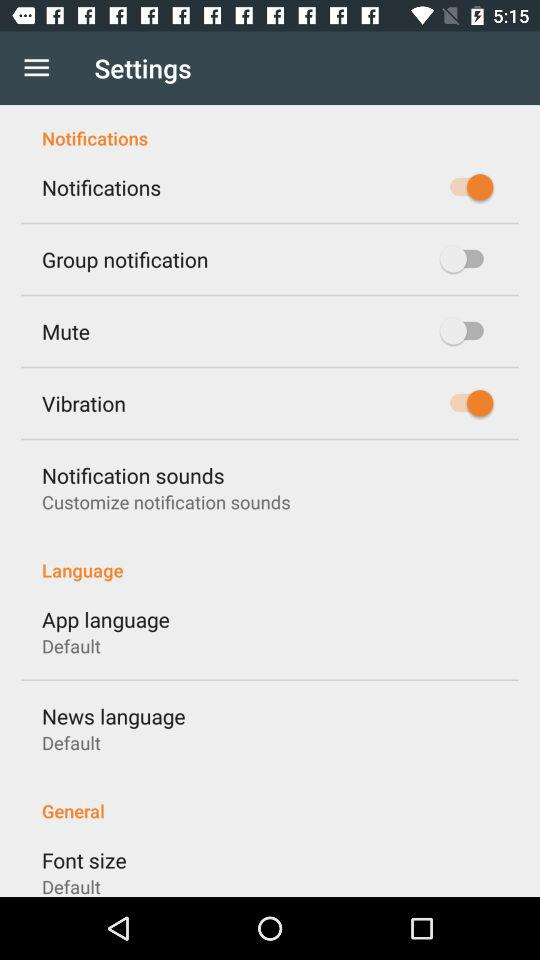What's the status of "Vibration"? The status is on. 